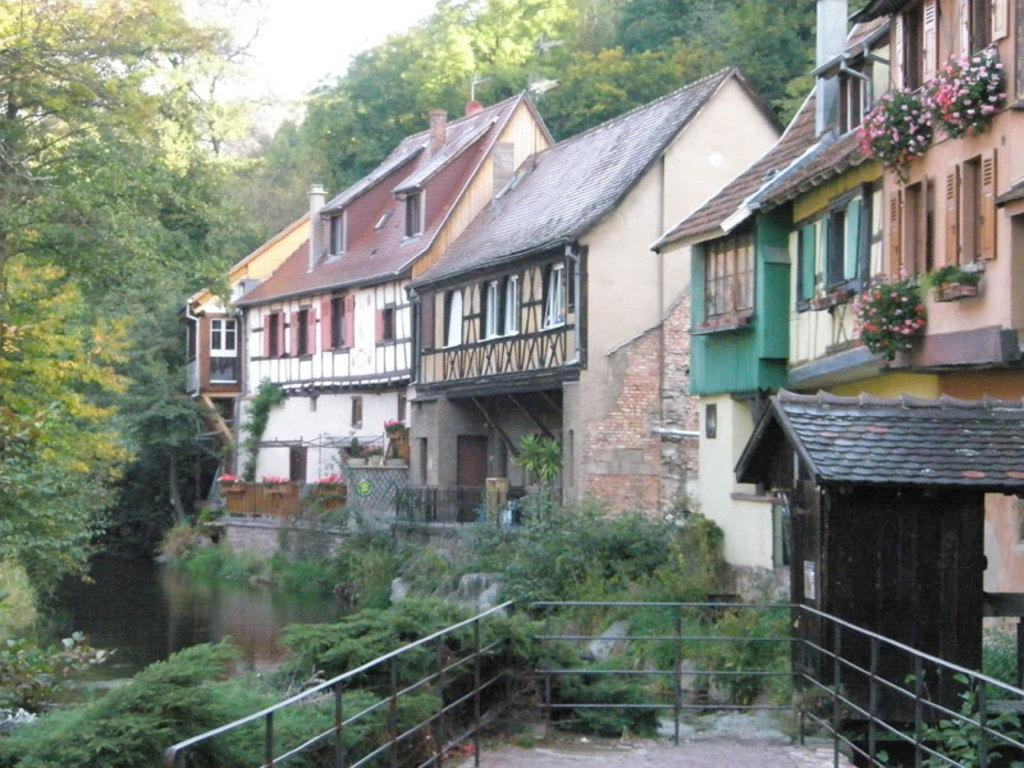What type of path can be seen in the image? There is a trail in the image. What other natural elements are present in the image? There are plants and trees visible in the image. Are there any man-made structures in the image? Yes, there are buildings in the image. What is the water in the image used for? The water's purpose cannot be determined from the image. What is visible in the background of the image? The sky and trees are visible in the background of the image. Are there any plants near the buildings? Yes, there are plants near the buildings. Where is the cannon located in the image? There is no cannon present in the image. What type of tin is used to make the buildings in the image? The buildings in the image are not made of tin, and their construction materials cannot be determined from the image. 